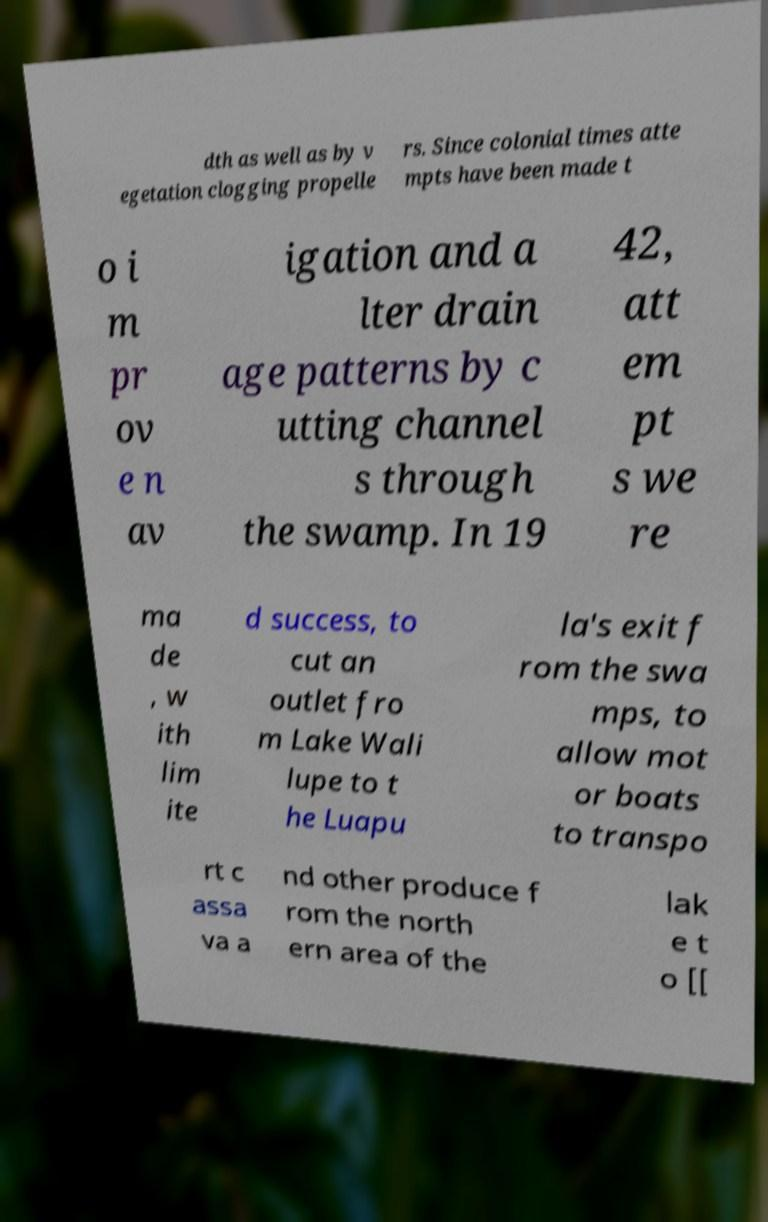I need the written content from this picture converted into text. Can you do that? dth as well as by v egetation clogging propelle rs. Since colonial times atte mpts have been made t o i m pr ov e n av igation and a lter drain age patterns by c utting channel s through the swamp. In 19 42, att em pt s we re ma de , w ith lim ite d success, to cut an outlet fro m Lake Wali lupe to t he Luapu la's exit f rom the swa mps, to allow mot or boats to transpo rt c assa va a nd other produce f rom the north ern area of the lak e t o [[ 